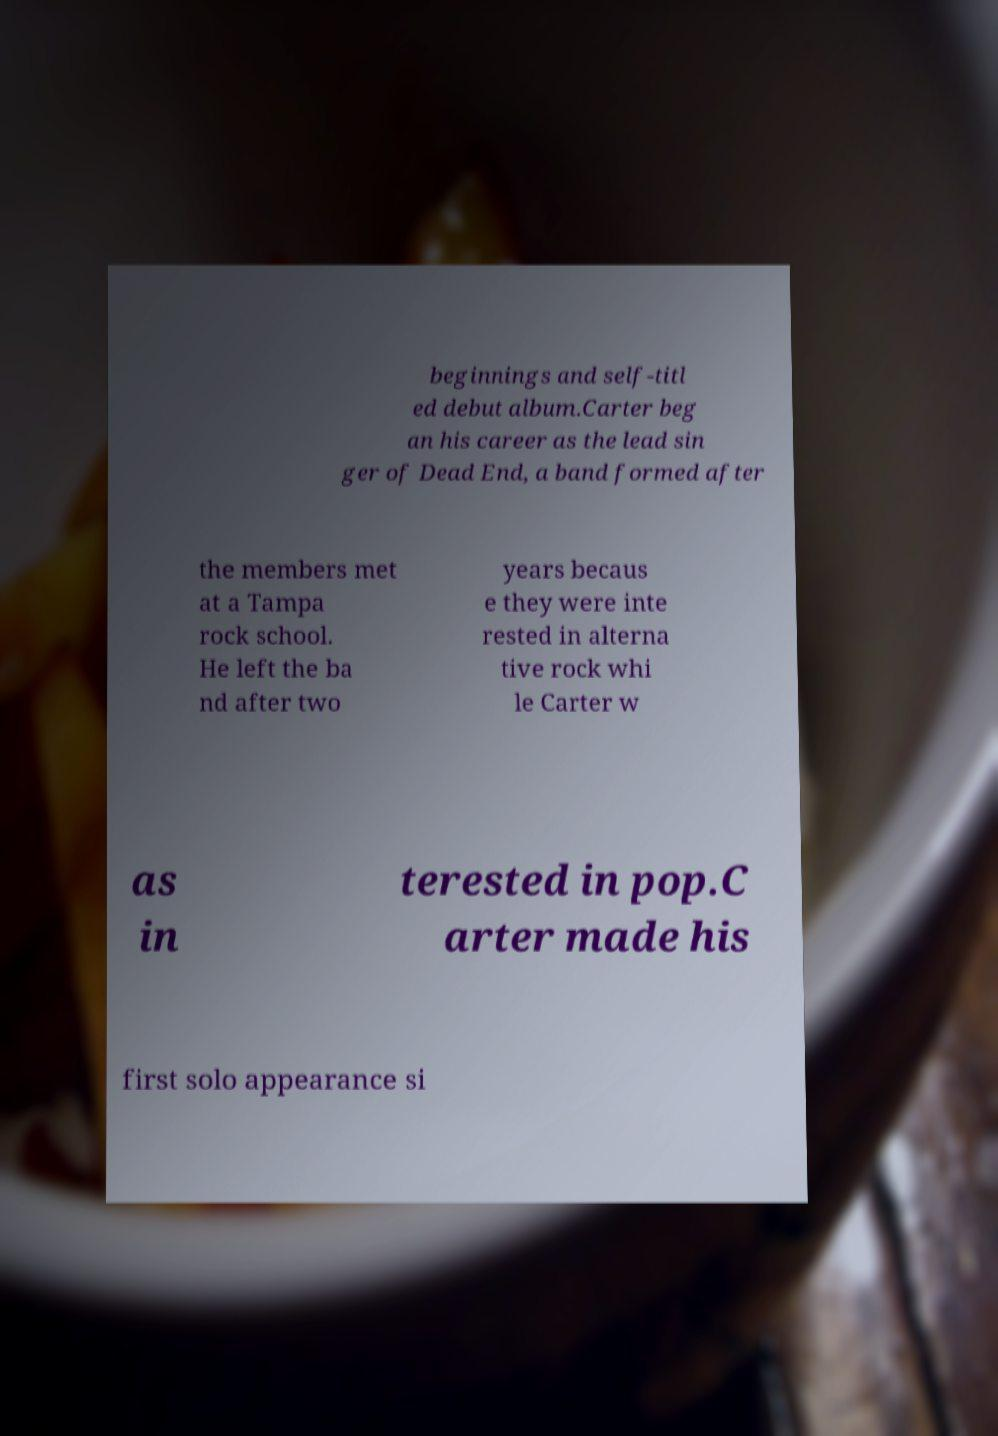What messages or text are displayed in this image? I need them in a readable, typed format. beginnings and self-titl ed debut album.Carter beg an his career as the lead sin ger of Dead End, a band formed after the members met at a Tampa rock school. He left the ba nd after two years becaus e they were inte rested in alterna tive rock whi le Carter w as in terested in pop.C arter made his first solo appearance si 